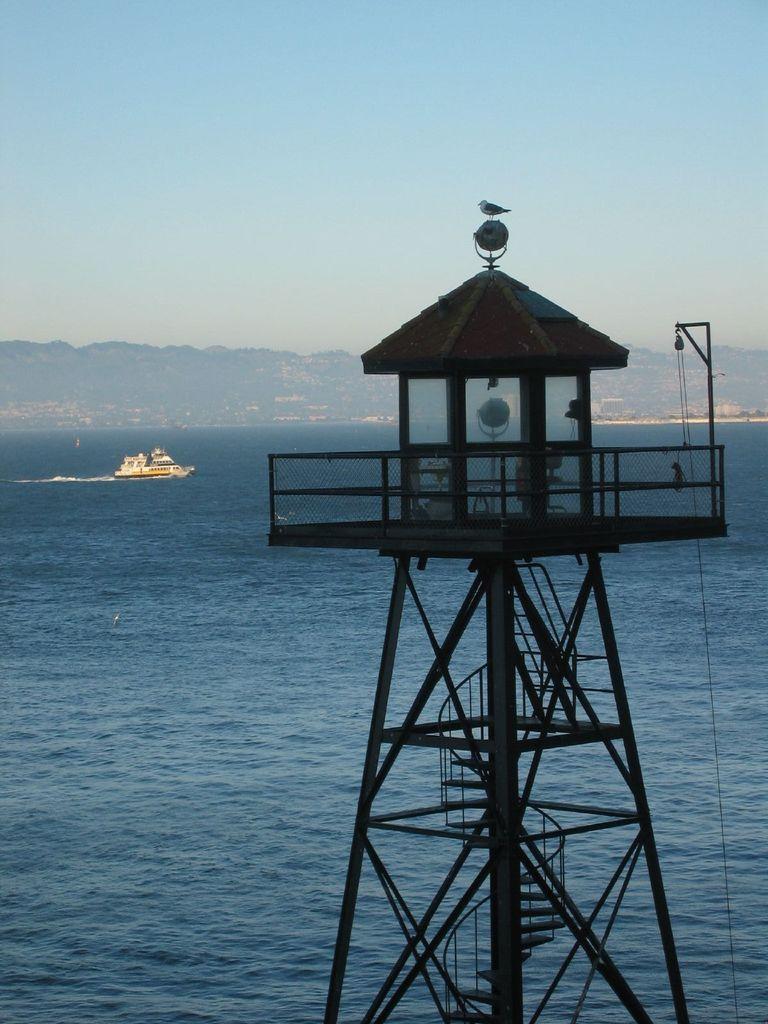Describe this image in one or two sentences. In this image, there is an ocean with a ship sailing on it and there is a tower at the front. At the end of the ocean we can see some hills. 